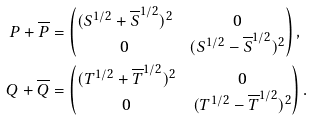<formula> <loc_0><loc_0><loc_500><loc_500>P + \overline { P } & = \begin{pmatrix} ( S ^ { 1 / 2 } + { \overline { S } } ^ { 1 / 2 } ) ^ { 2 } & 0 \\ 0 & ( S ^ { 1 / 2 } - { \overline { S } } ^ { 1 / 2 } ) ^ { 2 } \end{pmatrix} , \\ Q + \overline { Q } & = \begin{pmatrix} ( T ^ { 1 / 2 } + { \overline { T } } ^ { 1 / 2 } ) ^ { 2 } & 0 \\ 0 & ( T ^ { 1 / 2 } - { \overline { T } } ^ { 1 / 2 } ) ^ { 2 } \end{pmatrix} .</formula> 